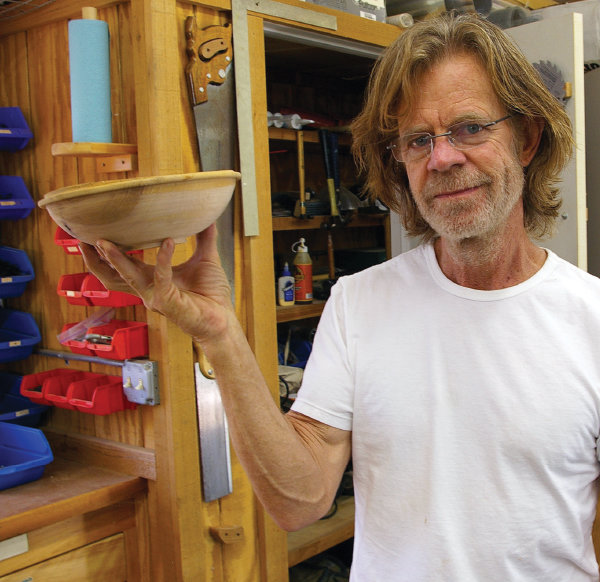Explain the visual content of the image in great detail. The image displays an older man with shoulder-length gray hair, glasses resting on his nose, and a light beard, holding a wooden bowl. He is standing in a well-organized woodshop, which is filled with various woodworking tools and supplies neatly arranged on shelves and hanging from the walls. He wears a plain white T-shirt, and his expression is gentle with a slight smile, indicating a moment of satisfaction or pride in his craft. This scene not only showcases his skill in woodworking but also a personal joy in his hobby or profession. 